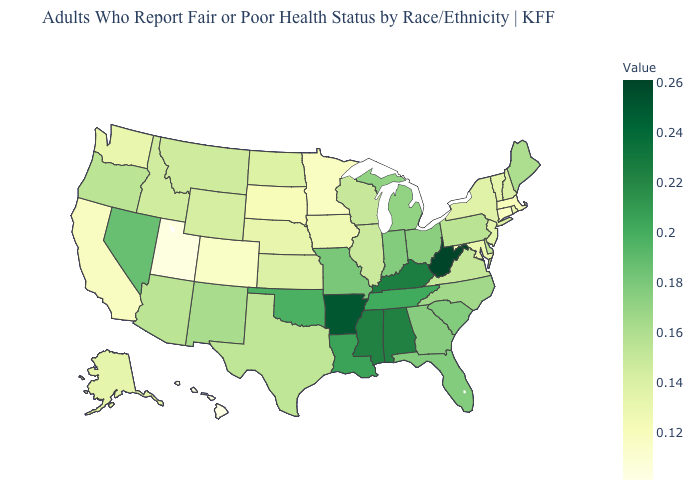Which states have the highest value in the USA?
Short answer required. West Virginia. Which states have the lowest value in the USA?
Keep it brief. Hawaii. Which states have the highest value in the USA?
Answer briefly. West Virginia. Is the legend a continuous bar?
Give a very brief answer. Yes. Which states have the highest value in the USA?
Quick response, please. West Virginia. Which states have the lowest value in the MidWest?
Give a very brief answer. Minnesota. 